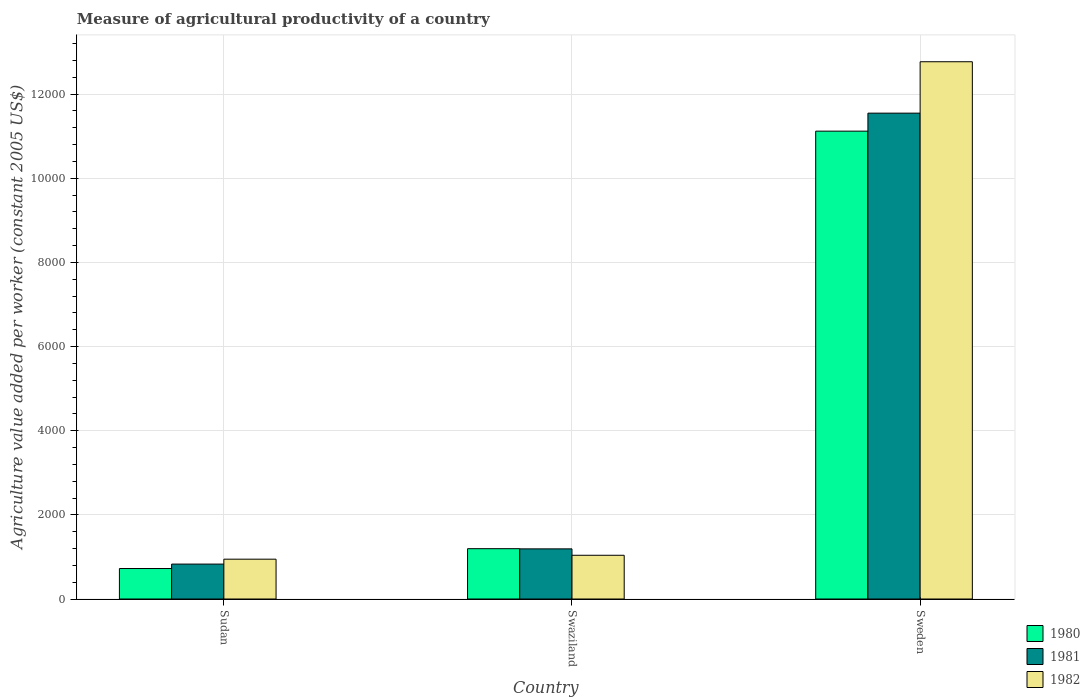How many different coloured bars are there?
Your response must be concise. 3. How many bars are there on the 2nd tick from the left?
Make the answer very short. 3. How many bars are there on the 2nd tick from the right?
Ensure brevity in your answer.  3. What is the label of the 3rd group of bars from the left?
Give a very brief answer. Sweden. What is the measure of agricultural productivity in 1981 in Sweden?
Offer a very short reply. 1.15e+04. Across all countries, what is the maximum measure of agricultural productivity in 1982?
Keep it short and to the point. 1.28e+04. Across all countries, what is the minimum measure of agricultural productivity in 1982?
Ensure brevity in your answer.  946.58. In which country was the measure of agricultural productivity in 1982 maximum?
Your answer should be compact. Sweden. In which country was the measure of agricultural productivity in 1981 minimum?
Offer a very short reply. Sudan. What is the total measure of agricultural productivity in 1982 in the graph?
Your answer should be compact. 1.48e+04. What is the difference between the measure of agricultural productivity in 1982 in Sudan and that in Sweden?
Your answer should be compact. -1.18e+04. What is the difference between the measure of agricultural productivity in 1980 in Sweden and the measure of agricultural productivity in 1982 in Swaziland?
Provide a short and direct response. 1.01e+04. What is the average measure of agricultural productivity in 1981 per country?
Offer a terse response. 4522.73. What is the difference between the measure of agricultural productivity of/in 1982 and measure of agricultural productivity of/in 1981 in Swaziland?
Your answer should be very brief. -152.24. What is the ratio of the measure of agricultural productivity in 1981 in Sudan to that in Swaziland?
Provide a succinct answer. 0.7. Is the measure of agricultural productivity in 1981 in Swaziland less than that in Sweden?
Your answer should be compact. Yes. What is the difference between the highest and the second highest measure of agricultural productivity in 1982?
Your response must be concise. 1.18e+04. What is the difference between the highest and the lowest measure of agricultural productivity in 1982?
Provide a short and direct response. 1.18e+04. What does the 1st bar from the right in Swaziland represents?
Provide a succinct answer. 1982. Is it the case that in every country, the sum of the measure of agricultural productivity in 1980 and measure of agricultural productivity in 1981 is greater than the measure of agricultural productivity in 1982?
Keep it short and to the point. Yes. Are all the bars in the graph horizontal?
Provide a short and direct response. No. What is the difference between two consecutive major ticks on the Y-axis?
Offer a very short reply. 2000. Does the graph contain grids?
Your answer should be very brief. Yes. What is the title of the graph?
Your response must be concise. Measure of agricultural productivity of a country. Does "2003" appear as one of the legend labels in the graph?
Your answer should be compact. No. What is the label or title of the Y-axis?
Keep it short and to the point. Agriculture value added per worker (constant 2005 US$). What is the Agriculture value added per worker (constant 2005 US$) in 1980 in Sudan?
Give a very brief answer. 724.57. What is the Agriculture value added per worker (constant 2005 US$) in 1981 in Sudan?
Provide a short and direct response. 829.99. What is the Agriculture value added per worker (constant 2005 US$) of 1982 in Sudan?
Offer a very short reply. 946.58. What is the Agriculture value added per worker (constant 2005 US$) of 1980 in Swaziland?
Make the answer very short. 1196. What is the Agriculture value added per worker (constant 2005 US$) in 1981 in Swaziland?
Your answer should be compact. 1191.63. What is the Agriculture value added per worker (constant 2005 US$) in 1982 in Swaziland?
Provide a succinct answer. 1039.39. What is the Agriculture value added per worker (constant 2005 US$) of 1980 in Sweden?
Provide a succinct answer. 1.11e+04. What is the Agriculture value added per worker (constant 2005 US$) in 1981 in Sweden?
Your response must be concise. 1.15e+04. What is the Agriculture value added per worker (constant 2005 US$) of 1982 in Sweden?
Offer a terse response. 1.28e+04. Across all countries, what is the maximum Agriculture value added per worker (constant 2005 US$) in 1980?
Offer a terse response. 1.11e+04. Across all countries, what is the maximum Agriculture value added per worker (constant 2005 US$) in 1981?
Your response must be concise. 1.15e+04. Across all countries, what is the maximum Agriculture value added per worker (constant 2005 US$) in 1982?
Keep it short and to the point. 1.28e+04. Across all countries, what is the minimum Agriculture value added per worker (constant 2005 US$) of 1980?
Provide a short and direct response. 724.57. Across all countries, what is the minimum Agriculture value added per worker (constant 2005 US$) in 1981?
Make the answer very short. 829.99. Across all countries, what is the minimum Agriculture value added per worker (constant 2005 US$) in 1982?
Offer a terse response. 946.58. What is the total Agriculture value added per worker (constant 2005 US$) in 1980 in the graph?
Your answer should be compact. 1.30e+04. What is the total Agriculture value added per worker (constant 2005 US$) in 1981 in the graph?
Ensure brevity in your answer.  1.36e+04. What is the total Agriculture value added per worker (constant 2005 US$) in 1982 in the graph?
Provide a short and direct response. 1.48e+04. What is the difference between the Agriculture value added per worker (constant 2005 US$) in 1980 in Sudan and that in Swaziland?
Your answer should be very brief. -471.43. What is the difference between the Agriculture value added per worker (constant 2005 US$) in 1981 in Sudan and that in Swaziland?
Offer a very short reply. -361.64. What is the difference between the Agriculture value added per worker (constant 2005 US$) in 1982 in Sudan and that in Swaziland?
Your answer should be very brief. -92.81. What is the difference between the Agriculture value added per worker (constant 2005 US$) of 1980 in Sudan and that in Sweden?
Provide a succinct answer. -1.04e+04. What is the difference between the Agriculture value added per worker (constant 2005 US$) of 1981 in Sudan and that in Sweden?
Give a very brief answer. -1.07e+04. What is the difference between the Agriculture value added per worker (constant 2005 US$) in 1982 in Sudan and that in Sweden?
Your answer should be compact. -1.18e+04. What is the difference between the Agriculture value added per worker (constant 2005 US$) in 1980 in Swaziland and that in Sweden?
Provide a short and direct response. -9923.05. What is the difference between the Agriculture value added per worker (constant 2005 US$) of 1981 in Swaziland and that in Sweden?
Give a very brief answer. -1.04e+04. What is the difference between the Agriculture value added per worker (constant 2005 US$) in 1982 in Swaziland and that in Sweden?
Offer a very short reply. -1.17e+04. What is the difference between the Agriculture value added per worker (constant 2005 US$) in 1980 in Sudan and the Agriculture value added per worker (constant 2005 US$) in 1981 in Swaziland?
Give a very brief answer. -467.06. What is the difference between the Agriculture value added per worker (constant 2005 US$) of 1980 in Sudan and the Agriculture value added per worker (constant 2005 US$) of 1982 in Swaziland?
Your response must be concise. -314.82. What is the difference between the Agriculture value added per worker (constant 2005 US$) in 1981 in Sudan and the Agriculture value added per worker (constant 2005 US$) in 1982 in Swaziland?
Ensure brevity in your answer.  -209.4. What is the difference between the Agriculture value added per worker (constant 2005 US$) of 1980 in Sudan and the Agriculture value added per worker (constant 2005 US$) of 1981 in Sweden?
Ensure brevity in your answer.  -1.08e+04. What is the difference between the Agriculture value added per worker (constant 2005 US$) of 1980 in Sudan and the Agriculture value added per worker (constant 2005 US$) of 1982 in Sweden?
Your response must be concise. -1.20e+04. What is the difference between the Agriculture value added per worker (constant 2005 US$) of 1981 in Sudan and the Agriculture value added per worker (constant 2005 US$) of 1982 in Sweden?
Provide a short and direct response. -1.19e+04. What is the difference between the Agriculture value added per worker (constant 2005 US$) in 1980 in Swaziland and the Agriculture value added per worker (constant 2005 US$) in 1981 in Sweden?
Your response must be concise. -1.04e+04. What is the difference between the Agriculture value added per worker (constant 2005 US$) of 1980 in Swaziland and the Agriculture value added per worker (constant 2005 US$) of 1982 in Sweden?
Ensure brevity in your answer.  -1.16e+04. What is the difference between the Agriculture value added per worker (constant 2005 US$) of 1981 in Swaziland and the Agriculture value added per worker (constant 2005 US$) of 1982 in Sweden?
Give a very brief answer. -1.16e+04. What is the average Agriculture value added per worker (constant 2005 US$) in 1980 per country?
Provide a succinct answer. 4346.54. What is the average Agriculture value added per worker (constant 2005 US$) of 1981 per country?
Keep it short and to the point. 4522.73. What is the average Agriculture value added per worker (constant 2005 US$) of 1982 per country?
Keep it short and to the point. 4918.15. What is the difference between the Agriculture value added per worker (constant 2005 US$) of 1980 and Agriculture value added per worker (constant 2005 US$) of 1981 in Sudan?
Give a very brief answer. -105.42. What is the difference between the Agriculture value added per worker (constant 2005 US$) of 1980 and Agriculture value added per worker (constant 2005 US$) of 1982 in Sudan?
Your answer should be very brief. -222.01. What is the difference between the Agriculture value added per worker (constant 2005 US$) of 1981 and Agriculture value added per worker (constant 2005 US$) of 1982 in Sudan?
Provide a short and direct response. -116.59. What is the difference between the Agriculture value added per worker (constant 2005 US$) in 1980 and Agriculture value added per worker (constant 2005 US$) in 1981 in Swaziland?
Make the answer very short. 4.37. What is the difference between the Agriculture value added per worker (constant 2005 US$) of 1980 and Agriculture value added per worker (constant 2005 US$) of 1982 in Swaziland?
Your response must be concise. 156.61. What is the difference between the Agriculture value added per worker (constant 2005 US$) in 1981 and Agriculture value added per worker (constant 2005 US$) in 1982 in Swaziland?
Provide a short and direct response. 152.24. What is the difference between the Agriculture value added per worker (constant 2005 US$) in 1980 and Agriculture value added per worker (constant 2005 US$) in 1981 in Sweden?
Offer a very short reply. -427.51. What is the difference between the Agriculture value added per worker (constant 2005 US$) in 1980 and Agriculture value added per worker (constant 2005 US$) in 1982 in Sweden?
Make the answer very short. -1649.43. What is the difference between the Agriculture value added per worker (constant 2005 US$) of 1981 and Agriculture value added per worker (constant 2005 US$) of 1982 in Sweden?
Provide a succinct answer. -1221.92. What is the ratio of the Agriculture value added per worker (constant 2005 US$) in 1980 in Sudan to that in Swaziland?
Provide a short and direct response. 0.61. What is the ratio of the Agriculture value added per worker (constant 2005 US$) in 1981 in Sudan to that in Swaziland?
Provide a short and direct response. 0.7. What is the ratio of the Agriculture value added per worker (constant 2005 US$) of 1982 in Sudan to that in Swaziland?
Offer a terse response. 0.91. What is the ratio of the Agriculture value added per worker (constant 2005 US$) of 1980 in Sudan to that in Sweden?
Your answer should be very brief. 0.07. What is the ratio of the Agriculture value added per worker (constant 2005 US$) of 1981 in Sudan to that in Sweden?
Your response must be concise. 0.07. What is the ratio of the Agriculture value added per worker (constant 2005 US$) of 1982 in Sudan to that in Sweden?
Provide a short and direct response. 0.07. What is the ratio of the Agriculture value added per worker (constant 2005 US$) of 1980 in Swaziland to that in Sweden?
Offer a terse response. 0.11. What is the ratio of the Agriculture value added per worker (constant 2005 US$) in 1981 in Swaziland to that in Sweden?
Offer a terse response. 0.1. What is the ratio of the Agriculture value added per worker (constant 2005 US$) of 1982 in Swaziland to that in Sweden?
Keep it short and to the point. 0.08. What is the difference between the highest and the second highest Agriculture value added per worker (constant 2005 US$) in 1980?
Ensure brevity in your answer.  9923.05. What is the difference between the highest and the second highest Agriculture value added per worker (constant 2005 US$) of 1981?
Give a very brief answer. 1.04e+04. What is the difference between the highest and the second highest Agriculture value added per worker (constant 2005 US$) in 1982?
Make the answer very short. 1.17e+04. What is the difference between the highest and the lowest Agriculture value added per worker (constant 2005 US$) of 1980?
Give a very brief answer. 1.04e+04. What is the difference between the highest and the lowest Agriculture value added per worker (constant 2005 US$) in 1981?
Provide a succinct answer. 1.07e+04. What is the difference between the highest and the lowest Agriculture value added per worker (constant 2005 US$) in 1982?
Offer a very short reply. 1.18e+04. 